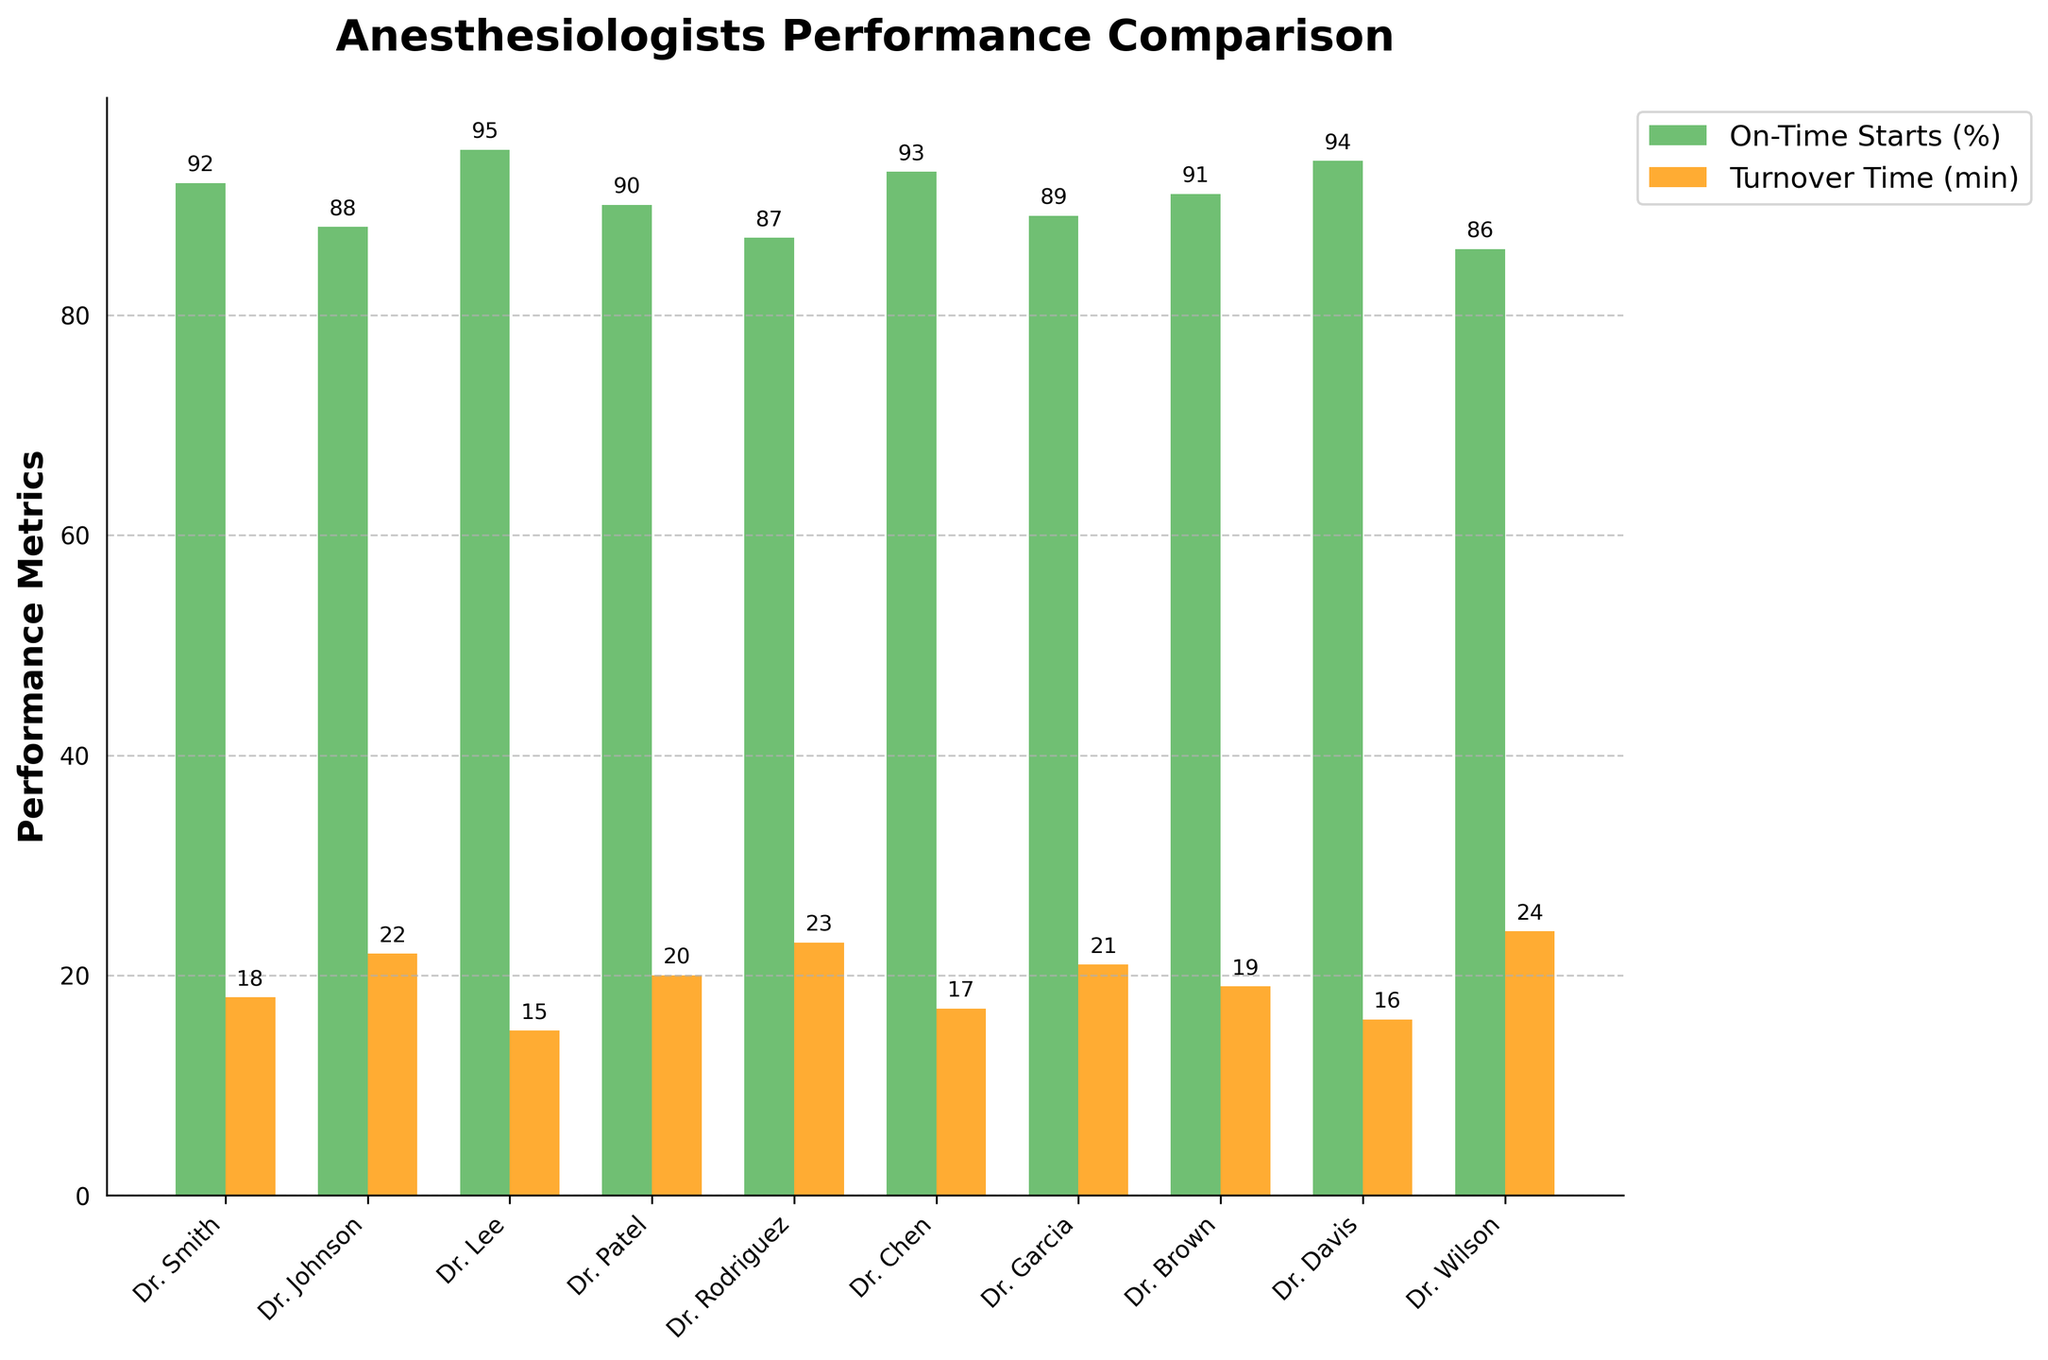What's the average percentage of On-Time Starts across all anesthesiologists? Sum the percentages of On-Time Starts for all anesthesiologists and divide by the number of anesthesiologists. (92 + 88 + 95 + 90 + 87 + 93 + 89 + 91 + 94 + 86) / 10 = 90.5
Answer: 90.5% Which anesthesiologist has the longest Turnover Time? Compare the heights of the orange bars representing Turnover Time and identify the anesthesiologist with the highest bar. Dr. Wilson has the highest Turnover Time with a value of 24 minutes.
Answer: Dr. Wilson Who has a higher On-Time Start percentage: Dr. Smith or Dr. Patel? Compare the green bars of Dr. Smith and Dr. Patel to see which is taller. Dr. Smith has 92%, and Dr. Patel has 90%.
Answer: Dr. Smith By how many minutes is Dr. Rodriguez's Turnover Time longer than Dr. Lee's? Subtract Dr. Lee's Turnover Time from Dr. Rodriguez's Turnover Time. 23 - 15 = 8 minutes.
Answer: 8 minutes Which anesthesiologist has both a high On-Time Start percentage (over 90%) and a short Turnover Time (15-17 minutes)? Identify anesthesiologists with an On-Time Start percentage over 90, then check if their Turnover Time falls within 15-17 minutes. Both Dr. Chen (93%, 17 minutes) and Dr. Davis (94%, 16 minutes) meet these criteria.
Answer: Dr. Chen and Dr. Davis What is the difference between the highest and lowest On-Time Start percentages? Find the highest and lowest percentages of On-Time Starts and subtract the lowest from the highest. The highest is Dr. Lee with 95%, and the lowest is Dr. Wilson with 86%. 95 - 86 = 9%.
Answer: 9% How does Dr. Johnson's performance in On-Time Starts compare to Dr. Brown's? Compare the green bars of Dr. Johnson and Dr. Brown. Dr. Johnson has 88%, and Dr. Brown has 91%. Therefore, Dr. Brown has a higher On-Time Start percentage.
Answer: Dr. Brown is higher Who are the top 3 anesthesiologists with the best On-Time Start percentages? Identify the three tallest green bars. Dr. Lee (95%), Dr. Davis (94%), and Dr. Chen (93%) have the highest On-Time Start percentages.
Answer: Dr. Lee, Dr. Davis, and Dr. Chen What’s the average Turnover Time for the anesthesiologists with On-Time Start percentages above 90%? Identify the Turnover Times for anesthesiologists with On-Time Starts above 90%. Dr. Smith (18), Dr. Lee (15), Dr. Chen (17), Dr. Davis (16), Dr. Brown (19). Calculate the average: (18 + 15 + 17 + 16 + 19) / 5 = 17
Answer: 17 minutes 